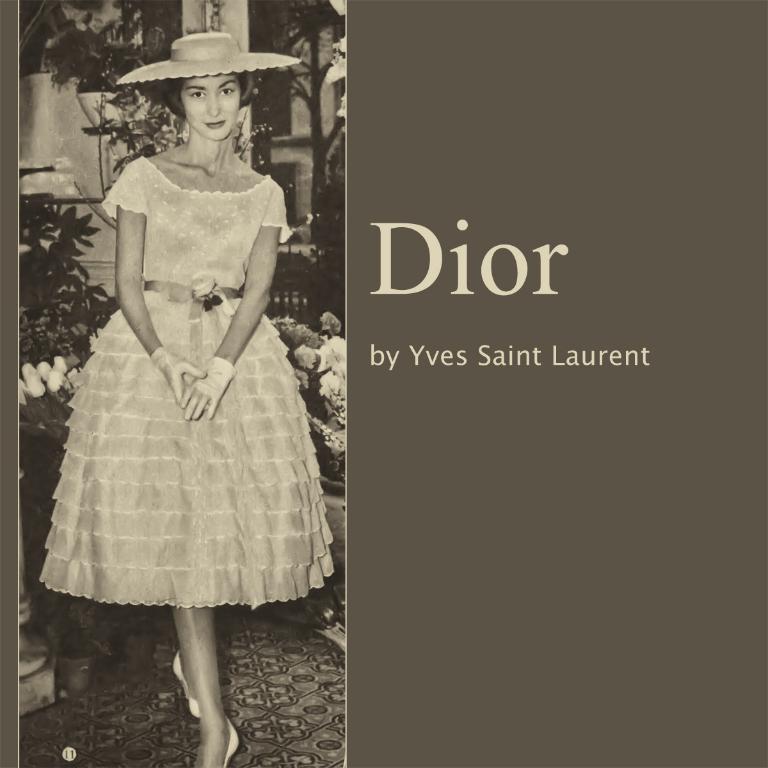What is probably the name of the woman?
Your response must be concise. Yves saint laurent. What is the company name?
Your answer should be compact. Dior. 